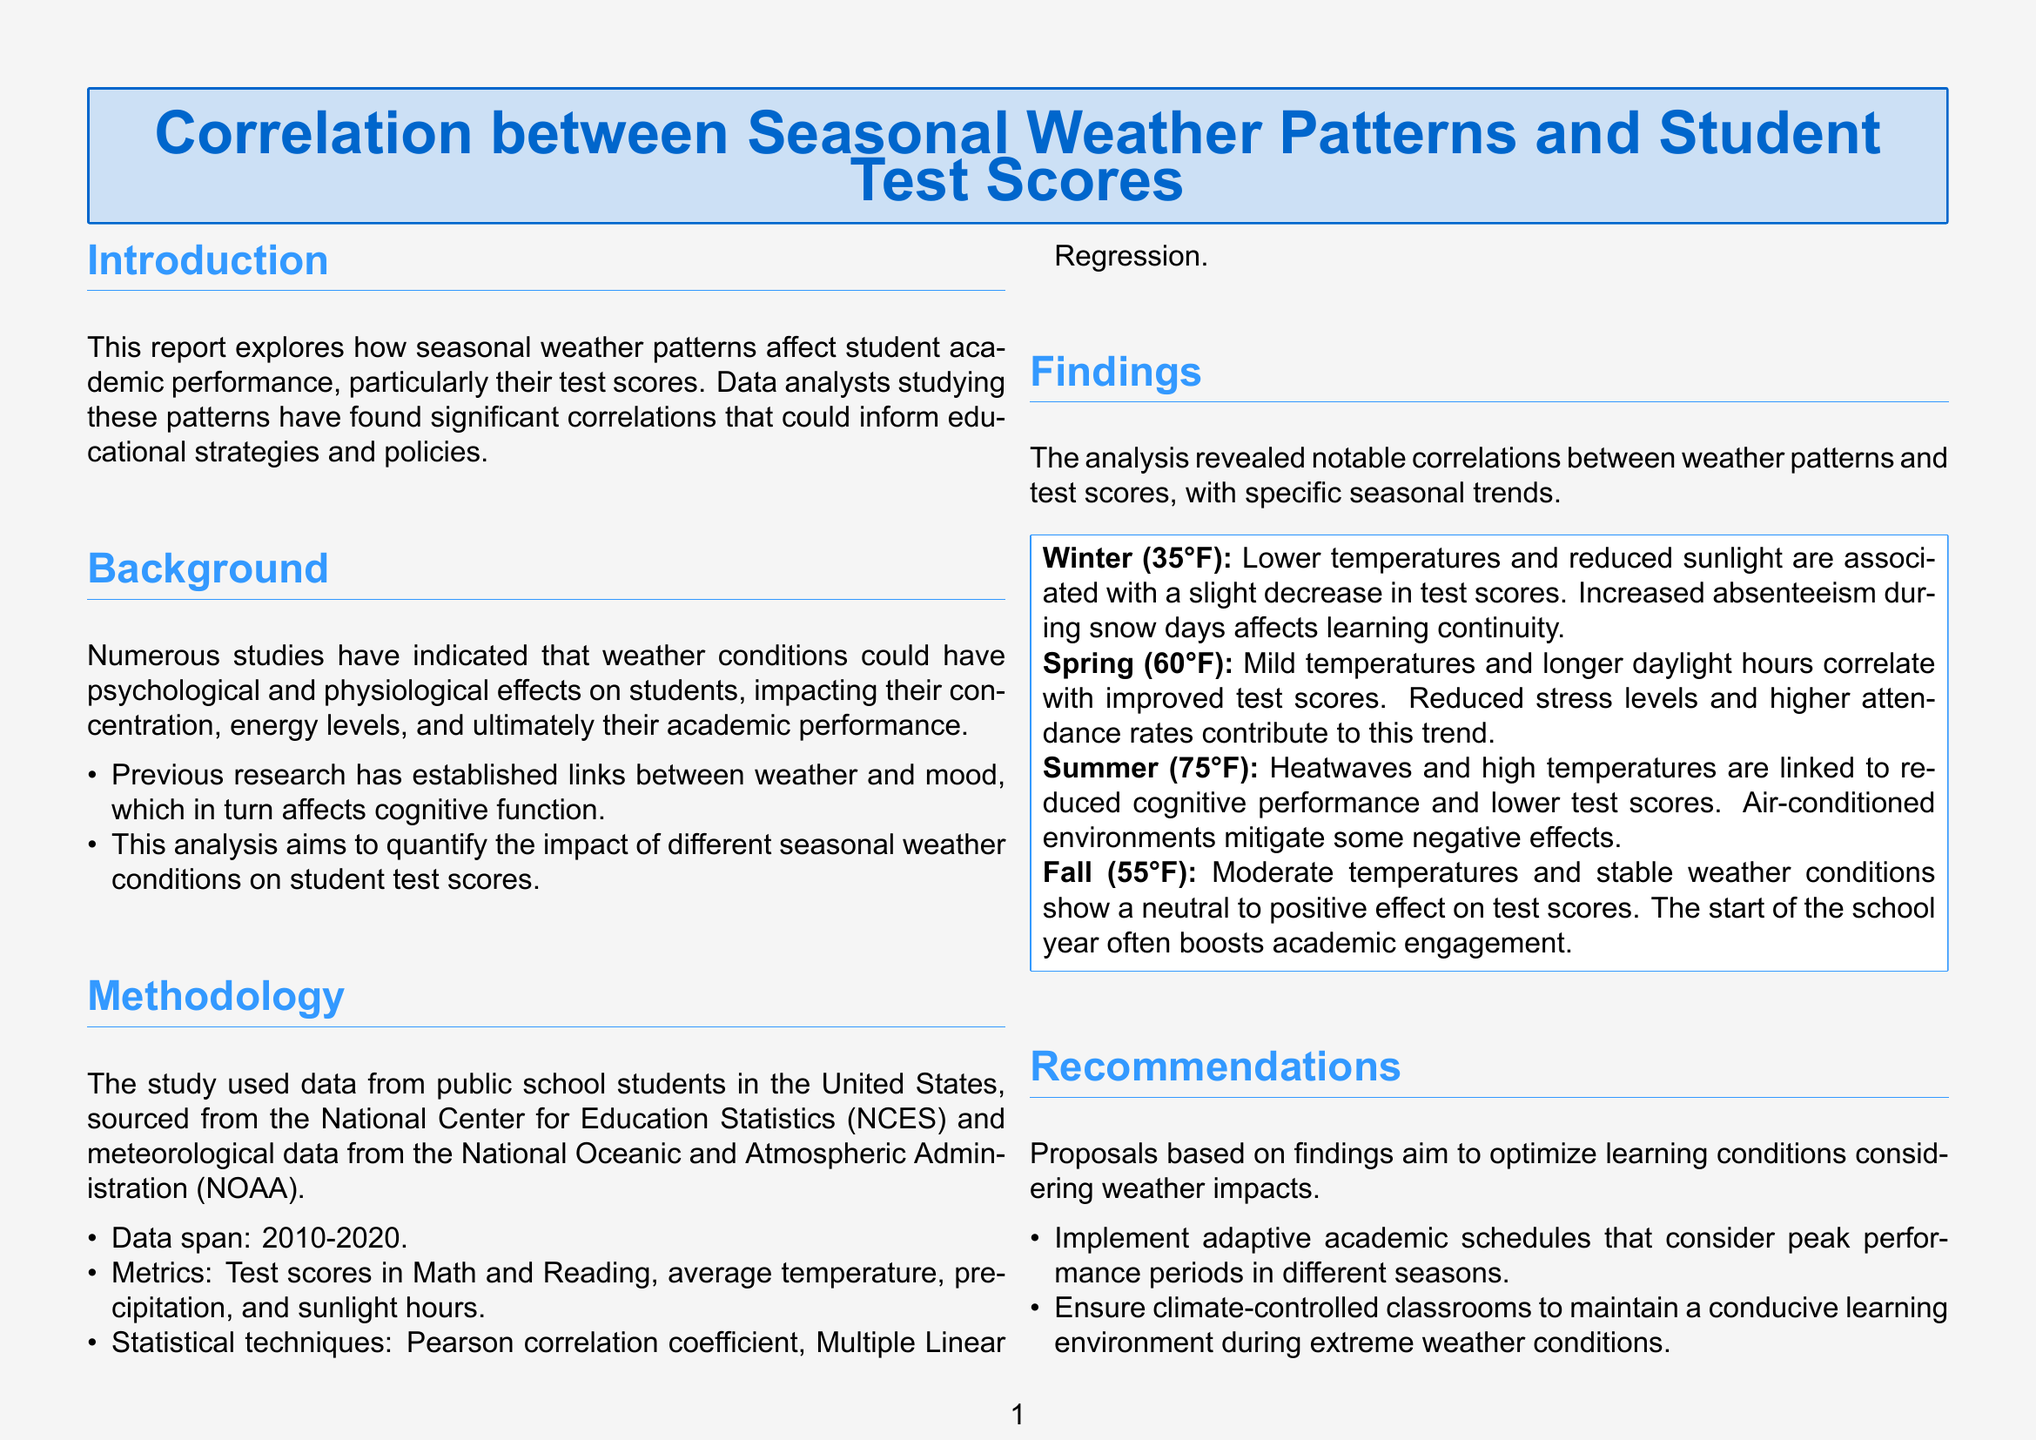What time period does the study cover? The period of the study spans from 2010 to 2020, as stated in the Methodology section.
Answer: 2010-2020 What is the impact of winter weather on test scores? The report notes that lower temperatures and reduced sunlight are associated with a slight decrease in test scores during winter.
Answer: Decrease Which statistical techniques were used in the analysis? The Methodology section lists the statistical techniques as Pearson correlation coefficient and Multiple Linear Regression.
Answer: Pearson correlation coefficient, Multiple Linear Regression What weather conditions are correlated with improved test scores in spring? The report mentions mild temperatures and longer daylight hours as correlated with improved test scores in spring.
Answer: Mild temperatures and longer daylight hours What recommendation is made regarding classroom conditions during extreme weather? The Recommendations section suggests ensuring climate-controlled classrooms to maintain a conducive learning environment.
Answer: Climate-controlled classrooms What effect does summer heat have on cognitive performance? The report states that heatwaves and high temperatures are linked to reduced cognitive performance.
Answer: Reduced cognitive performance What unique challenges do each season present according to the conclusion? According to the conclusion, each season has unique challenges and opportunities impacting student test scores.
Answer: Unique challenges and opportunities What is the average temperature in fall mentioned in the report? The report specifies the average temperature in fall as 55°F in the findings section.
Answer: 55°F 